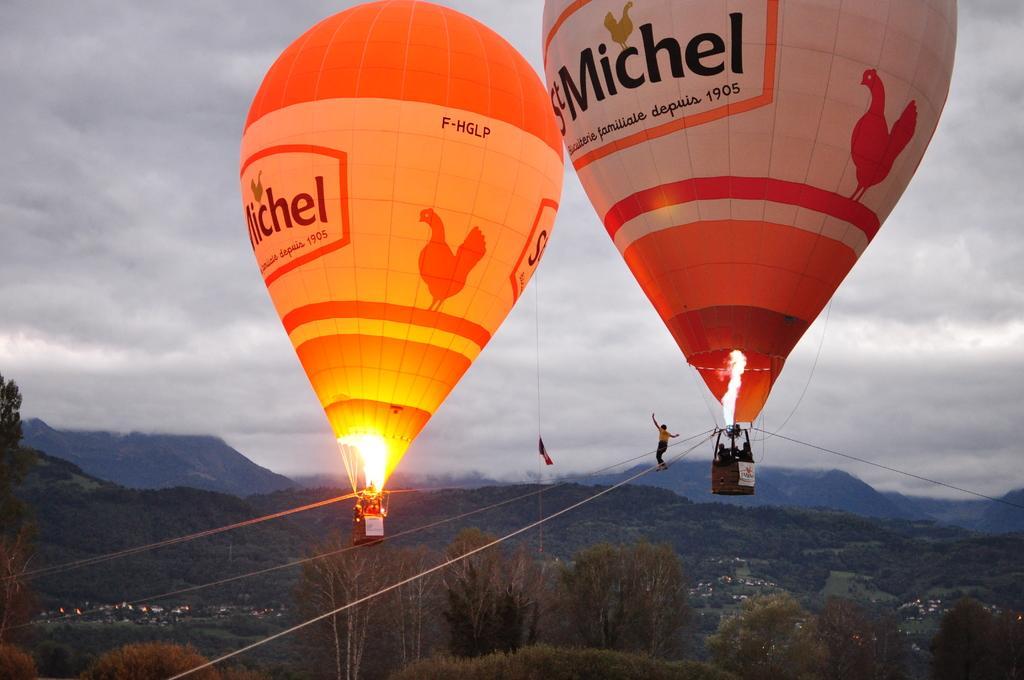Can you describe this image briefly? This image consist of parachutes in which we can see the fire. And there are few persons in this image. At the bottom, there are trees. In the background, there are mountains. At the top, there are clouds in the sky. 